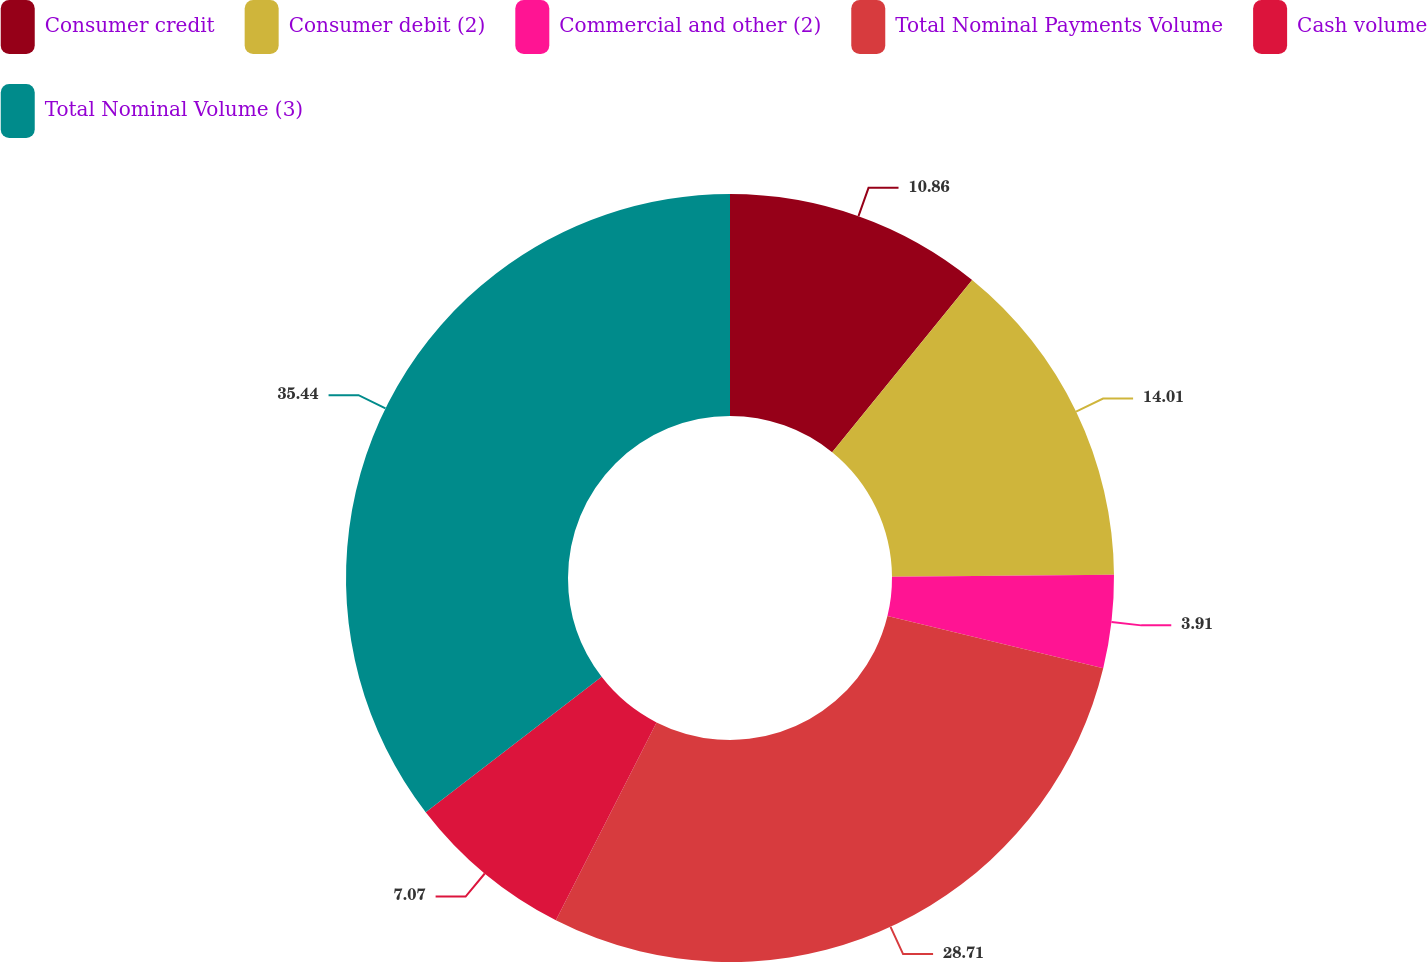Convert chart. <chart><loc_0><loc_0><loc_500><loc_500><pie_chart><fcel>Consumer credit<fcel>Consumer debit (2)<fcel>Commercial and other (2)<fcel>Total Nominal Payments Volume<fcel>Cash volume<fcel>Total Nominal Volume (3)<nl><fcel>10.86%<fcel>14.01%<fcel>3.91%<fcel>28.71%<fcel>7.07%<fcel>35.44%<nl></chart> 